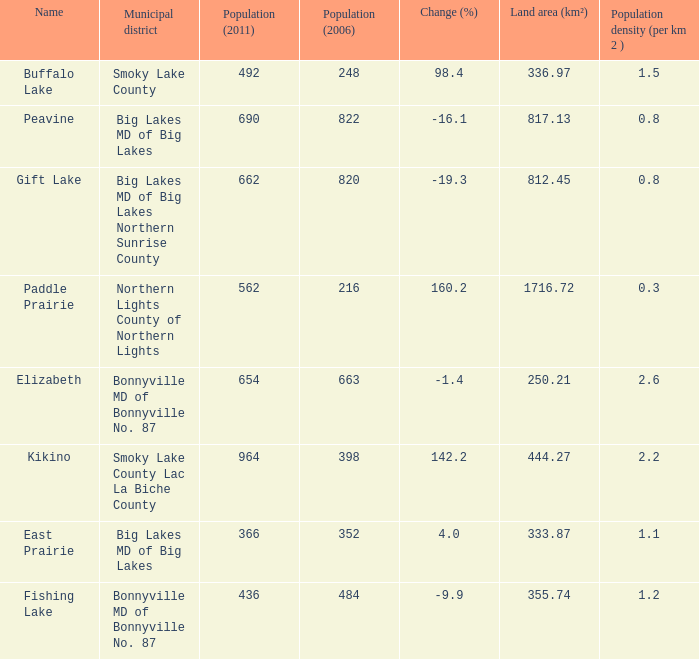What place is there a change of -19.3? 1.0. 